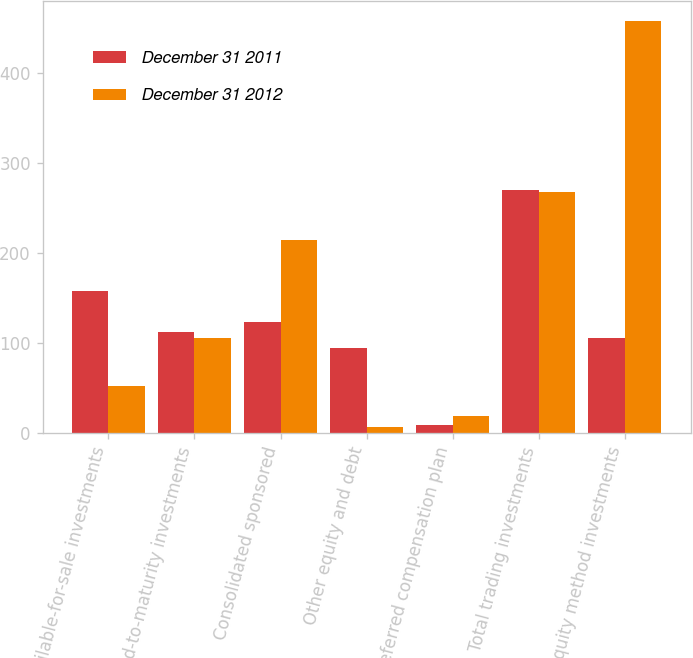Convert chart. <chart><loc_0><loc_0><loc_500><loc_500><stacked_bar_chart><ecel><fcel>Available-for-sale investments<fcel>Held-to-maturity investments<fcel>Consolidated sponsored<fcel>Other equity and debt<fcel>Deferred compensation plan<fcel>Total trading investments<fcel>Equity method investments<nl><fcel>December 31 2011<fcel>158<fcel>112<fcel>123<fcel>94<fcel>9<fcel>270<fcel>105<nl><fcel>December 31 2012<fcel>52<fcel>105<fcel>214<fcel>7<fcel>19<fcel>267<fcel>457<nl></chart> 